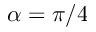Convert formula to latex. <formula><loc_0><loc_0><loc_500><loc_500>\alpha = \pi / 4</formula> 